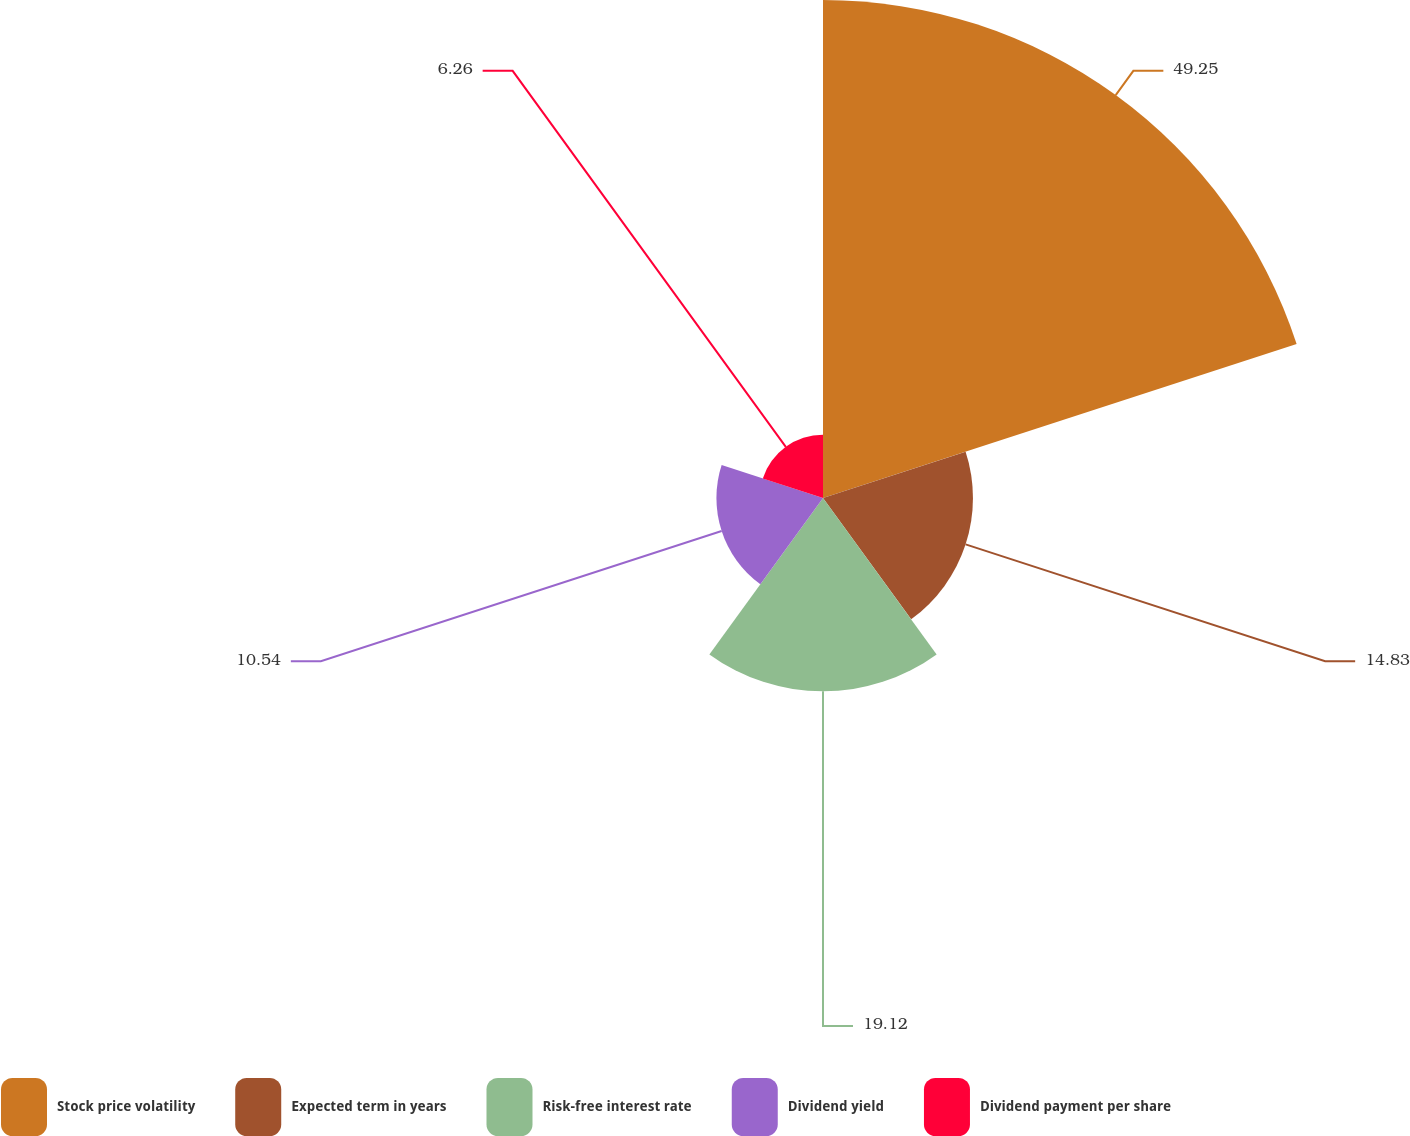Convert chart. <chart><loc_0><loc_0><loc_500><loc_500><pie_chart><fcel>Stock price volatility<fcel>Expected term in years<fcel>Risk-free interest rate<fcel>Dividend yield<fcel>Dividend payment per share<nl><fcel>49.25%<fcel>14.83%<fcel>19.12%<fcel>10.54%<fcel>6.26%<nl></chart> 